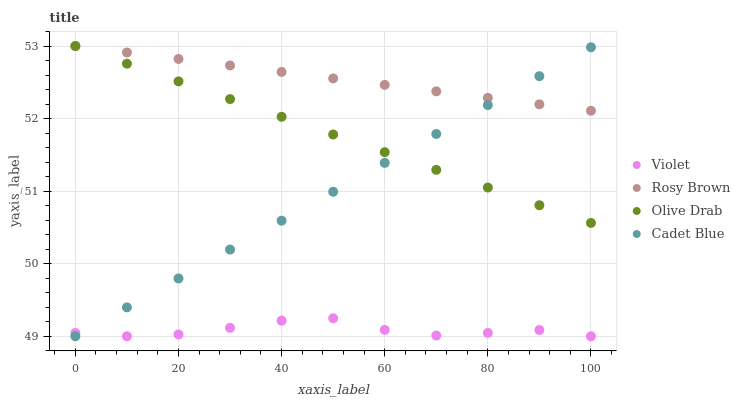Does Violet have the minimum area under the curve?
Answer yes or no. Yes. Does Rosy Brown have the maximum area under the curve?
Answer yes or no. Yes. Does Olive Drab have the minimum area under the curve?
Answer yes or no. No. Does Olive Drab have the maximum area under the curve?
Answer yes or no. No. Is Rosy Brown the smoothest?
Answer yes or no. Yes. Is Violet the roughest?
Answer yes or no. Yes. Is Olive Drab the smoothest?
Answer yes or no. No. Is Olive Drab the roughest?
Answer yes or no. No. Does Cadet Blue have the lowest value?
Answer yes or no. Yes. Does Olive Drab have the lowest value?
Answer yes or no. No. Does Olive Drab have the highest value?
Answer yes or no. Yes. Does Violet have the highest value?
Answer yes or no. No. Is Violet less than Rosy Brown?
Answer yes or no. Yes. Is Rosy Brown greater than Violet?
Answer yes or no. Yes. Does Violet intersect Cadet Blue?
Answer yes or no. Yes. Is Violet less than Cadet Blue?
Answer yes or no. No. Is Violet greater than Cadet Blue?
Answer yes or no. No. Does Violet intersect Rosy Brown?
Answer yes or no. No. 